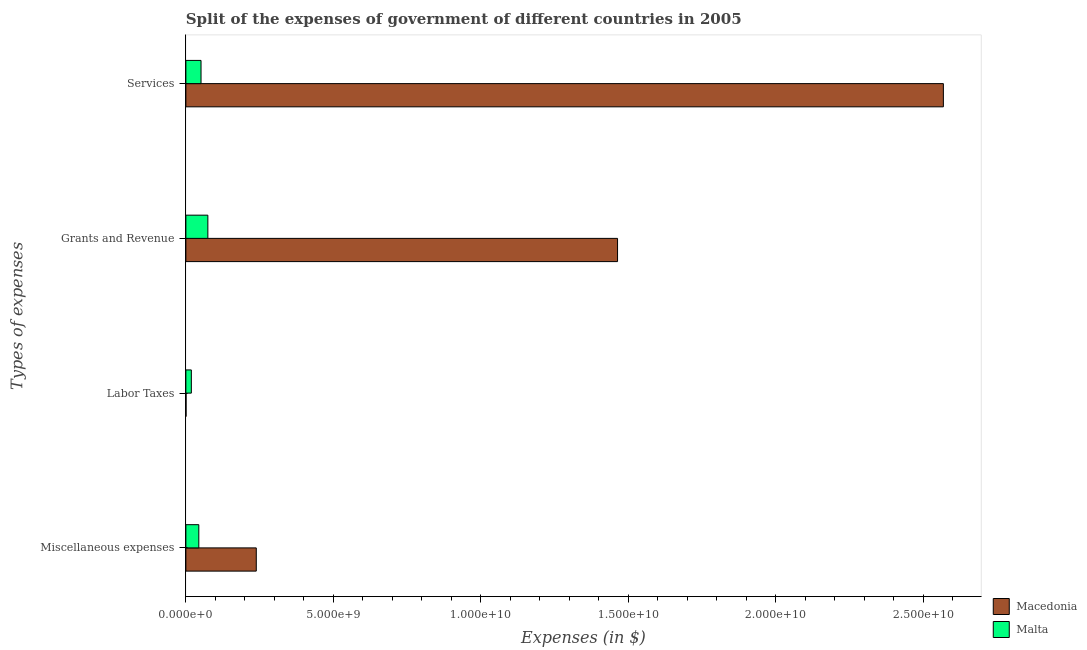Are the number of bars per tick equal to the number of legend labels?
Provide a short and direct response. Yes. How many bars are there on the 3rd tick from the bottom?
Your answer should be compact. 2. What is the label of the 2nd group of bars from the top?
Make the answer very short. Grants and Revenue. What is the amount spent on services in Malta?
Ensure brevity in your answer.  5.13e+08. Across all countries, what is the maximum amount spent on services?
Ensure brevity in your answer.  2.57e+1. Across all countries, what is the minimum amount spent on miscellaneous expenses?
Give a very brief answer. 4.38e+08. In which country was the amount spent on miscellaneous expenses maximum?
Your answer should be very brief. Macedonia. In which country was the amount spent on grants and revenue minimum?
Provide a succinct answer. Malta. What is the total amount spent on grants and revenue in the graph?
Offer a very short reply. 1.54e+1. What is the difference between the amount spent on labor taxes in Malta and that in Macedonia?
Give a very brief answer. 1.79e+08. What is the difference between the amount spent on miscellaneous expenses in Macedonia and the amount spent on services in Malta?
Make the answer very short. 1.87e+09. What is the average amount spent on miscellaneous expenses per country?
Provide a succinct answer. 1.41e+09. What is the difference between the amount spent on labor taxes and amount spent on grants and revenue in Malta?
Provide a succinct answer. -5.60e+08. In how many countries, is the amount spent on labor taxes greater than 5000000000 $?
Offer a very short reply. 0. What is the ratio of the amount spent on labor taxes in Malta to that in Macedonia?
Ensure brevity in your answer.  32.8. Is the amount spent on miscellaneous expenses in Macedonia less than that in Malta?
Make the answer very short. No. Is the difference between the amount spent on miscellaneous expenses in Macedonia and Malta greater than the difference between the amount spent on grants and revenue in Macedonia and Malta?
Your answer should be very brief. No. What is the difference between the highest and the second highest amount spent on services?
Keep it short and to the point. 2.52e+1. What is the difference between the highest and the lowest amount spent on miscellaneous expenses?
Your response must be concise. 1.95e+09. In how many countries, is the amount spent on services greater than the average amount spent on services taken over all countries?
Provide a short and direct response. 1. Is the sum of the amount spent on grants and revenue in Malta and Macedonia greater than the maximum amount spent on services across all countries?
Your answer should be very brief. No. Is it the case that in every country, the sum of the amount spent on miscellaneous expenses and amount spent on services is greater than the sum of amount spent on grants and revenue and amount spent on labor taxes?
Keep it short and to the point. No. What does the 1st bar from the top in Services represents?
Ensure brevity in your answer.  Malta. What does the 1st bar from the bottom in Services represents?
Keep it short and to the point. Macedonia. Is it the case that in every country, the sum of the amount spent on miscellaneous expenses and amount spent on labor taxes is greater than the amount spent on grants and revenue?
Provide a short and direct response. No. Are all the bars in the graph horizontal?
Give a very brief answer. Yes. What is the difference between two consecutive major ticks on the X-axis?
Ensure brevity in your answer.  5.00e+09. Are the values on the major ticks of X-axis written in scientific E-notation?
Make the answer very short. Yes. Does the graph contain any zero values?
Give a very brief answer. No. Does the graph contain grids?
Make the answer very short. No. How many legend labels are there?
Make the answer very short. 2. How are the legend labels stacked?
Provide a short and direct response. Vertical. What is the title of the graph?
Provide a short and direct response. Split of the expenses of government of different countries in 2005. Does "Japan" appear as one of the legend labels in the graph?
Make the answer very short. No. What is the label or title of the X-axis?
Provide a short and direct response. Expenses (in $). What is the label or title of the Y-axis?
Ensure brevity in your answer.  Types of expenses. What is the Expenses (in $) of Macedonia in Miscellaneous expenses?
Ensure brevity in your answer.  2.39e+09. What is the Expenses (in $) in Malta in Miscellaneous expenses?
Keep it short and to the point. 4.38e+08. What is the Expenses (in $) in Macedonia in Labor Taxes?
Your response must be concise. 5.64e+06. What is the Expenses (in $) of Malta in Labor Taxes?
Keep it short and to the point. 1.85e+08. What is the Expenses (in $) of Macedonia in Grants and Revenue?
Ensure brevity in your answer.  1.46e+1. What is the Expenses (in $) of Malta in Grants and Revenue?
Provide a short and direct response. 7.45e+08. What is the Expenses (in $) in Macedonia in Services?
Ensure brevity in your answer.  2.57e+1. What is the Expenses (in $) in Malta in Services?
Offer a terse response. 5.13e+08. Across all Types of expenses, what is the maximum Expenses (in $) of Macedonia?
Offer a very short reply. 2.57e+1. Across all Types of expenses, what is the maximum Expenses (in $) of Malta?
Your response must be concise. 7.45e+08. Across all Types of expenses, what is the minimum Expenses (in $) in Macedonia?
Your answer should be very brief. 5.64e+06. Across all Types of expenses, what is the minimum Expenses (in $) of Malta?
Your answer should be very brief. 1.85e+08. What is the total Expenses (in $) of Macedonia in the graph?
Your answer should be compact. 4.27e+1. What is the total Expenses (in $) of Malta in the graph?
Ensure brevity in your answer.  1.88e+09. What is the difference between the Expenses (in $) of Macedonia in Miscellaneous expenses and that in Labor Taxes?
Make the answer very short. 2.38e+09. What is the difference between the Expenses (in $) in Malta in Miscellaneous expenses and that in Labor Taxes?
Offer a very short reply. 2.53e+08. What is the difference between the Expenses (in $) in Macedonia in Miscellaneous expenses and that in Grants and Revenue?
Make the answer very short. -1.22e+1. What is the difference between the Expenses (in $) of Malta in Miscellaneous expenses and that in Grants and Revenue?
Provide a short and direct response. -3.06e+08. What is the difference between the Expenses (in $) in Macedonia in Miscellaneous expenses and that in Services?
Your answer should be very brief. -2.33e+1. What is the difference between the Expenses (in $) in Malta in Miscellaneous expenses and that in Services?
Provide a succinct answer. -7.50e+07. What is the difference between the Expenses (in $) in Macedonia in Labor Taxes and that in Grants and Revenue?
Your answer should be compact. -1.46e+1. What is the difference between the Expenses (in $) of Malta in Labor Taxes and that in Grants and Revenue?
Your response must be concise. -5.60e+08. What is the difference between the Expenses (in $) of Macedonia in Labor Taxes and that in Services?
Offer a terse response. -2.57e+1. What is the difference between the Expenses (in $) in Malta in Labor Taxes and that in Services?
Provide a succinct answer. -3.28e+08. What is the difference between the Expenses (in $) in Macedonia in Grants and Revenue and that in Services?
Your answer should be compact. -1.10e+1. What is the difference between the Expenses (in $) in Malta in Grants and Revenue and that in Services?
Provide a succinct answer. 2.31e+08. What is the difference between the Expenses (in $) in Macedonia in Miscellaneous expenses and the Expenses (in $) in Malta in Labor Taxes?
Offer a terse response. 2.20e+09. What is the difference between the Expenses (in $) of Macedonia in Miscellaneous expenses and the Expenses (in $) of Malta in Grants and Revenue?
Offer a very short reply. 1.64e+09. What is the difference between the Expenses (in $) in Macedonia in Miscellaneous expenses and the Expenses (in $) in Malta in Services?
Your answer should be very brief. 1.87e+09. What is the difference between the Expenses (in $) in Macedonia in Labor Taxes and the Expenses (in $) in Malta in Grants and Revenue?
Your answer should be compact. -7.39e+08. What is the difference between the Expenses (in $) of Macedonia in Labor Taxes and the Expenses (in $) of Malta in Services?
Provide a short and direct response. -5.08e+08. What is the difference between the Expenses (in $) in Macedonia in Grants and Revenue and the Expenses (in $) in Malta in Services?
Keep it short and to the point. 1.41e+1. What is the average Expenses (in $) in Macedonia per Types of expenses?
Keep it short and to the point. 1.07e+1. What is the average Expenses (in $) in Malta per Types of expenses?
Make the answer very short. 4.70e+08. What is the difference between the Expenses (in $) in Macedonia and Expenses (in $) in Malta in Miscellaneous expenses?
Keep it short and to the point. 1.95e+09. What is the difference between the Expenses (in $) of Macedonia and Expenses (in $) of Malta in Labor Taxes?
Offer a very short reply. -1.79e+08. What is the difference between the Expenses (in $) of Macedonia and Expenses (in $) of Malta in Grants and Revenue?
Your answer should be very brief. 1.39e+1. What is the difference between the Expenses (in $) in Macedonia and Expenses (in $) in Malta in Services?
Offer a terse response. 2.52e+1. What is the ratio of the Expenses (in $) in Macedonia in Miscellaneous expenses to that in Labor Taxes?
Ensure brevity in your answer.  422.86. What is the ratio of the Expenses (in $) of Malta in Miscellaneous expenses to that in Labor Taxes?
Give a very brief answer. 2.37. What is the ratio of the Expenses (in $) of Macedonia in Miscellaneous expenses to that in Grants and Revenue?
Offer a very short reply. 0.16. What is the ratio of the Expenses (in $) of Malta in Miscellaneous expenses to that in Grants and Revenue?
Give a very brief answer. 0.59. What is the ratio of the Expenses (in $) in Macedonia in Miscellaneous expenses to that in Services?
Your answer should be compact. 0.09. What is the ratio of the Expenses (in $) in Malta in Miscellaneous expenses to that in Services?
Offer a very short reply. 0.85. What is the ratio of the Expenses (in $) in Malta in Labor Taxes to that in Grants and Revenue?
Give a very brief answer. 0.25. What is the ratio of the Expenses (in $) of Macedonia in Labor Taxes to that in Services?
Keep it short and to the point. 0. What is the ratio of the Expenses (in $) in Malta in Labor Taxes to that in Services?
Make the answer very short. 0.36. What is the ratio of the Expenses (in $) in Macedonia in Grants and Revenue to that in Services?
Your response must be concise. 0.57. What is the ratio of the Expenses (in $) of Malta in Grants and Revenue to that in Services?
Your response must be concise. 1.45. What is the difference between the highest and the second highest Expenses (in $) of Macedonia?
Offer a terse response. 1.10e+1. What is the difference between the highest and the second highest Expenses (in $) in Malta?
Your response must be concise. 2.31e+08. What is the difference between the highest and the lowest Expenses (in $) of Macedonia?
Keep it short and to the point. 2.57e+1. What is the difference between the highest and the lowest Expenses (in $) of Malta?
Give a very brief answer. 5.60e+08. 